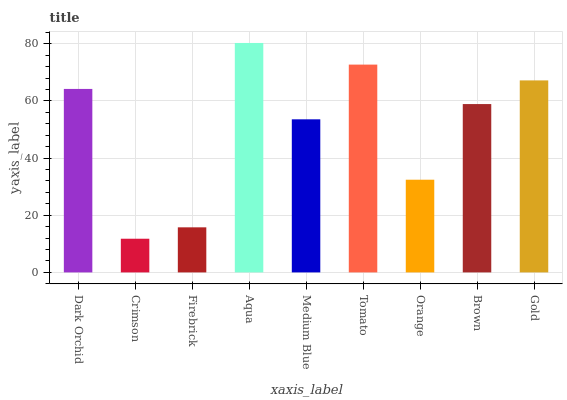Is Firebrick the minimum?
Answer yes or no. No. Is Firebrick the maximum?
Answer yes or no. No. Is Firebrick greater than Crimson?
Answer yes or no. Yes. Is Crimson less than Firebrick?
Answer yes or no. Yes. Is Crimson greater than Firebrick?
Answer yes or no. No. Is Firebrick less than Crimson?
Answer yes or no. No. Is Brown the high median?
Answer yes or no. Yes. Is Brown the low median?
Answer yes or no. Yes. Is Aqua the high median?
Answer yes or no. No. Is Aqua the low median?
Answer yes or no. No. 